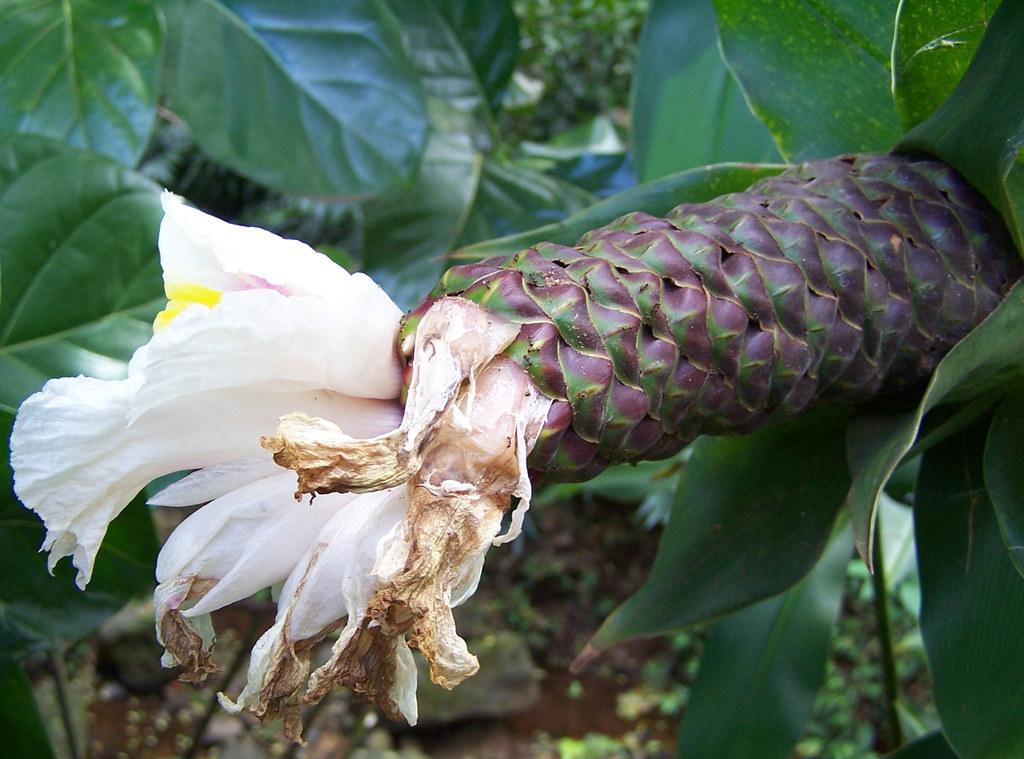Can you describe this image briefly? In this image I can see the flower in white and yellow color. Background I can see few plans in green color. 